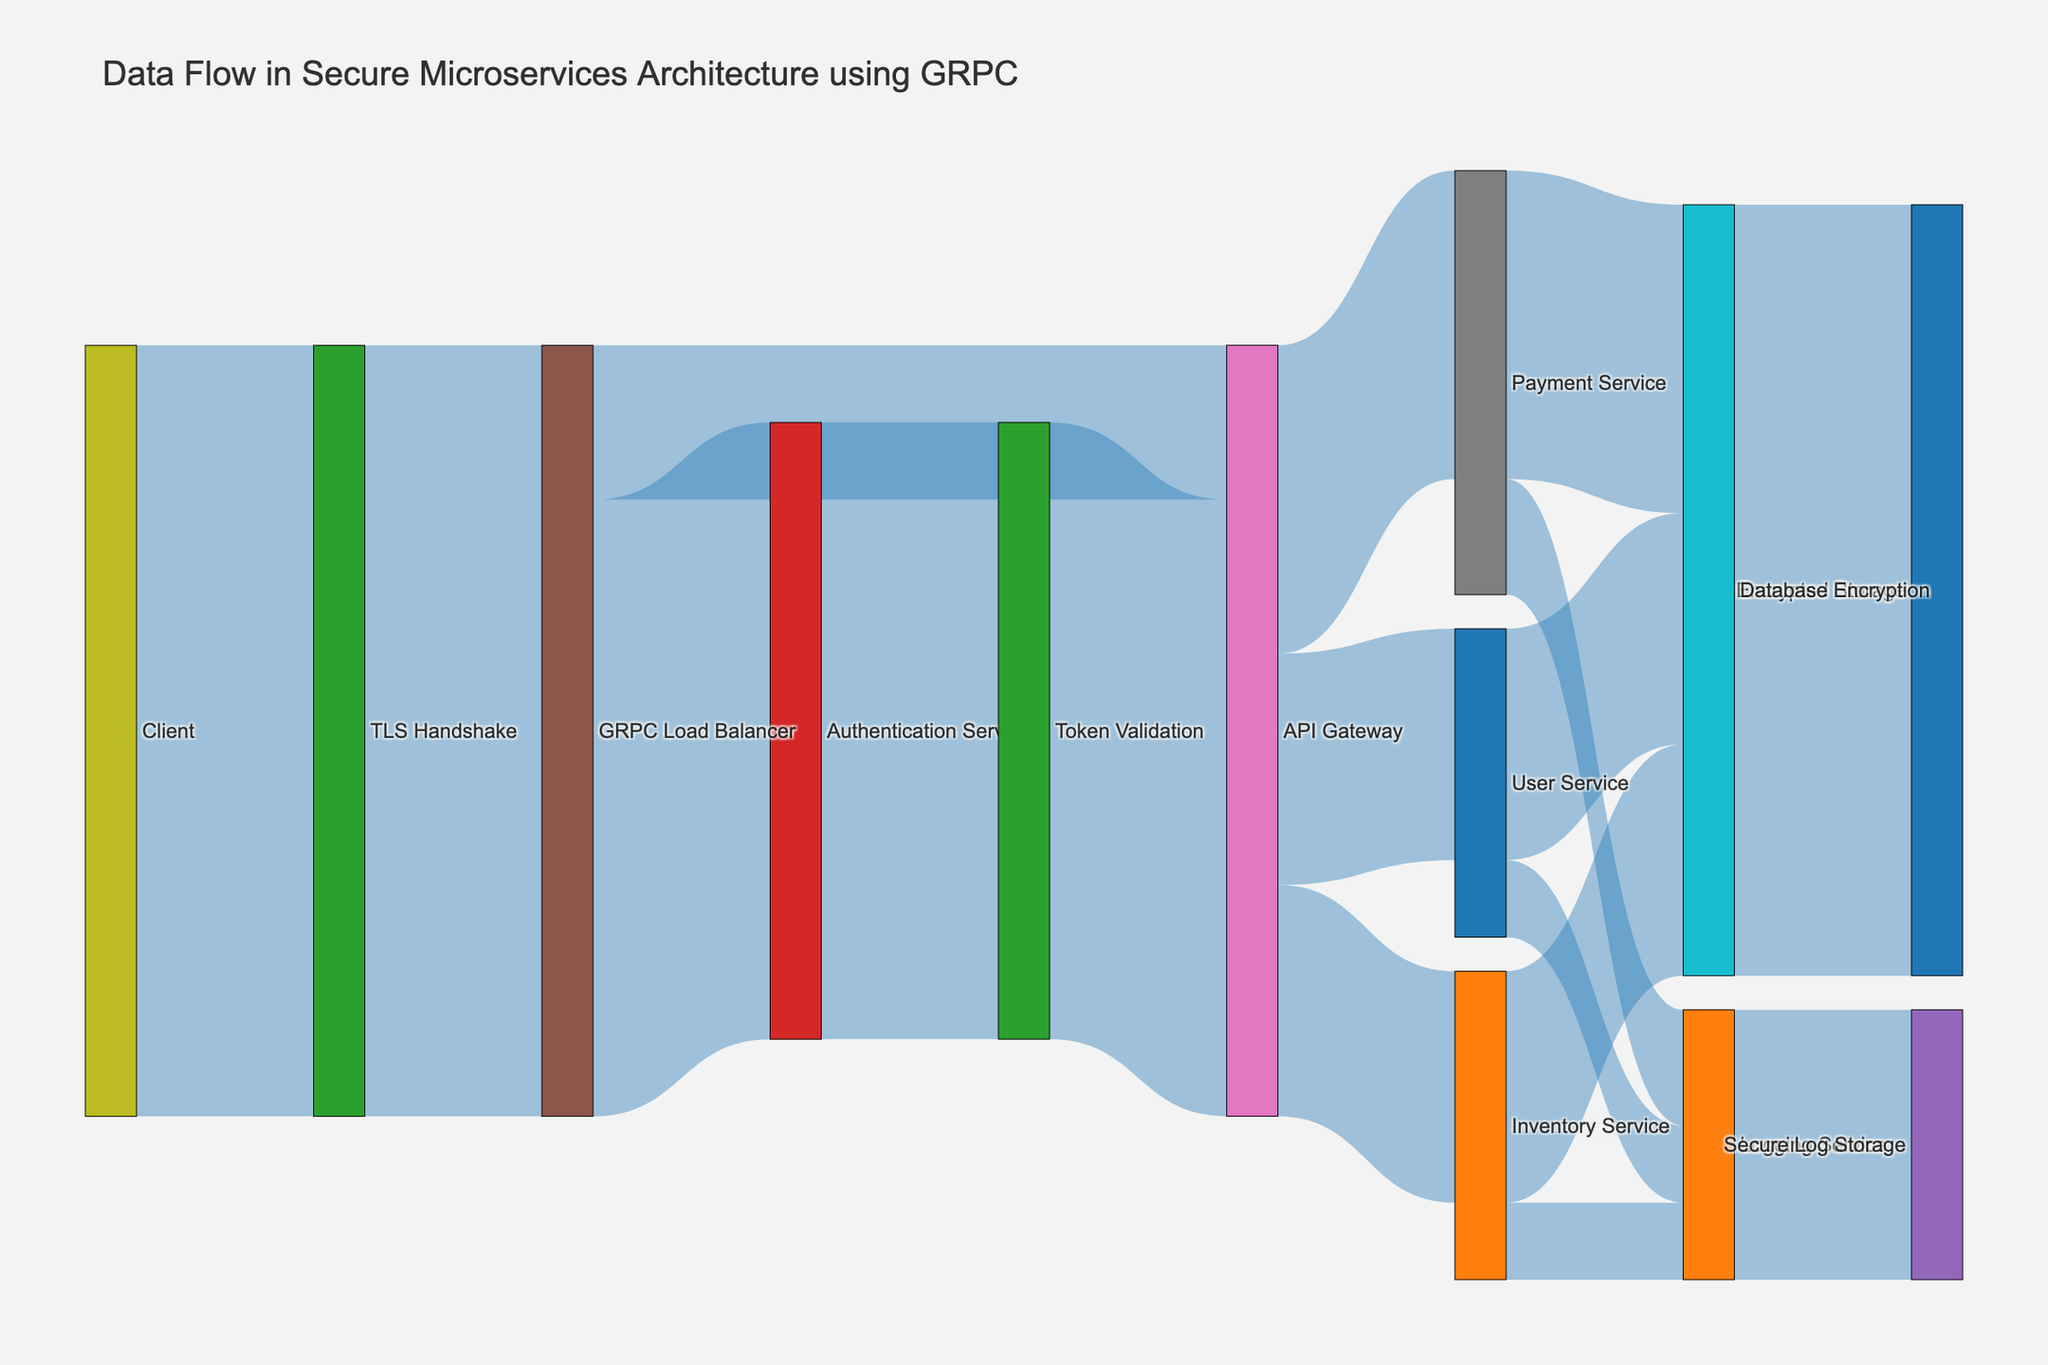How many different services are directly accessed from the API Gateway? By observing the connections from the API Gateway target node, we see that it directs its flow to the User Service, Payment Service, and Inventory Service.
Answer: 3 What's the combined value of data flows directed towards the Logging Service? Summing up the values from the User Service, Payment Service, and Inventory Service directed towards the Logging Service, we get 10 + 15 + 10 = 35.
Answer: 35 Which step has the highest incoming data flow? The node "Encrypted Storage" has the highest incoming data flow with a total of 100.
Answer: Encrypted Storage What is the flow value from the Authentication Service to the API Gateway? Observing the flow between Authentication Service and API Gateway, we see a value of 80.
Answer: 80 How does the data from the Client reach the Inventory Service? The data flow goes from Client -> TLS Handshake -> GRPC Load Balancer -> API Gateway -> Inventory Service.
Answer: 4 steps What is the flow value difference between data going to the User Service and Payment Service from the API Gateway? The flow value directed towards the User Service is 30 and towards the Payment Service is 40. The difference is 40 - 30 = 10.
Answer: 10 Which service has more encrypted storage data flow, User Service or Inventory Service? Both the User Service and Inventory Service have the same data flow towards the encrypted storage, which is 30 each.
Answer: Equal How many paths involve data flow through the GRPC Load Balancer? The GRPC Load Balancer has outgoing flows towards the Authentication Service (1), and the API Gateway (1), so there are 2 paths.
Answer: 2 Is the flow value higher through the Token Validation node or the Logging Service node? Comparing the incoming flow values, Token Validation has 80 and Logging Service has 35. Hence, Token Validation has a higher value.
Answer: Token Validation 